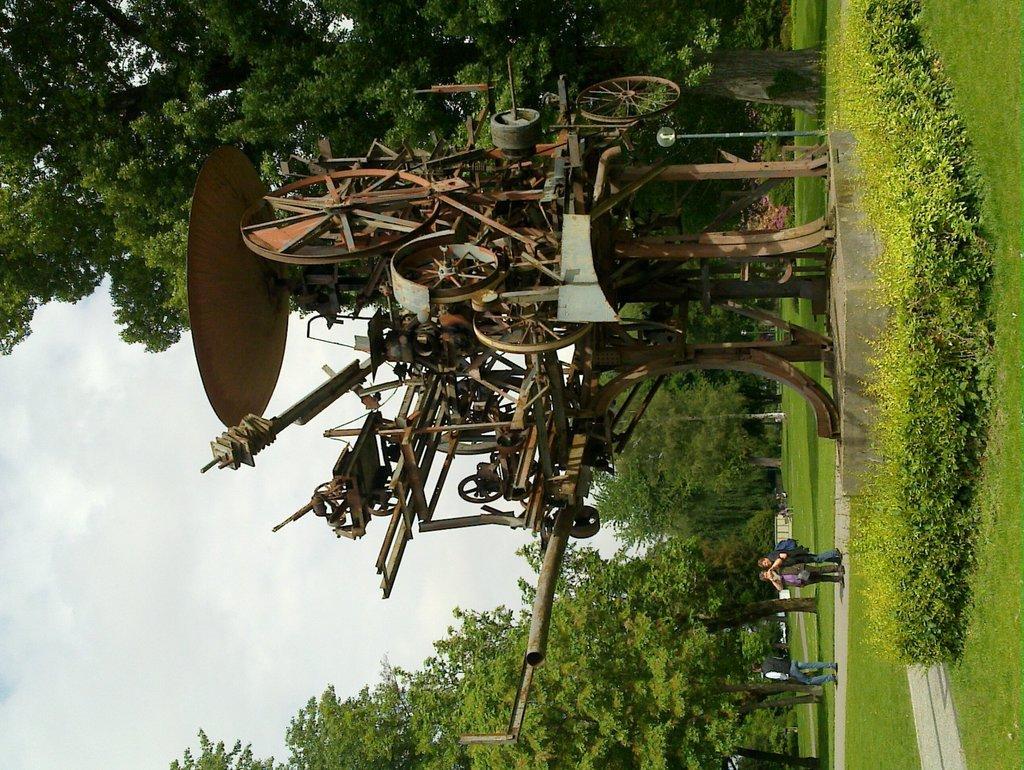How would you summarize this image in a sentence or two? In this image, we can see some trees and plants. There are three persons in the bottom right of the image wearing clothes. There is a machine in the middle of the image. There are clouds in the sky. 